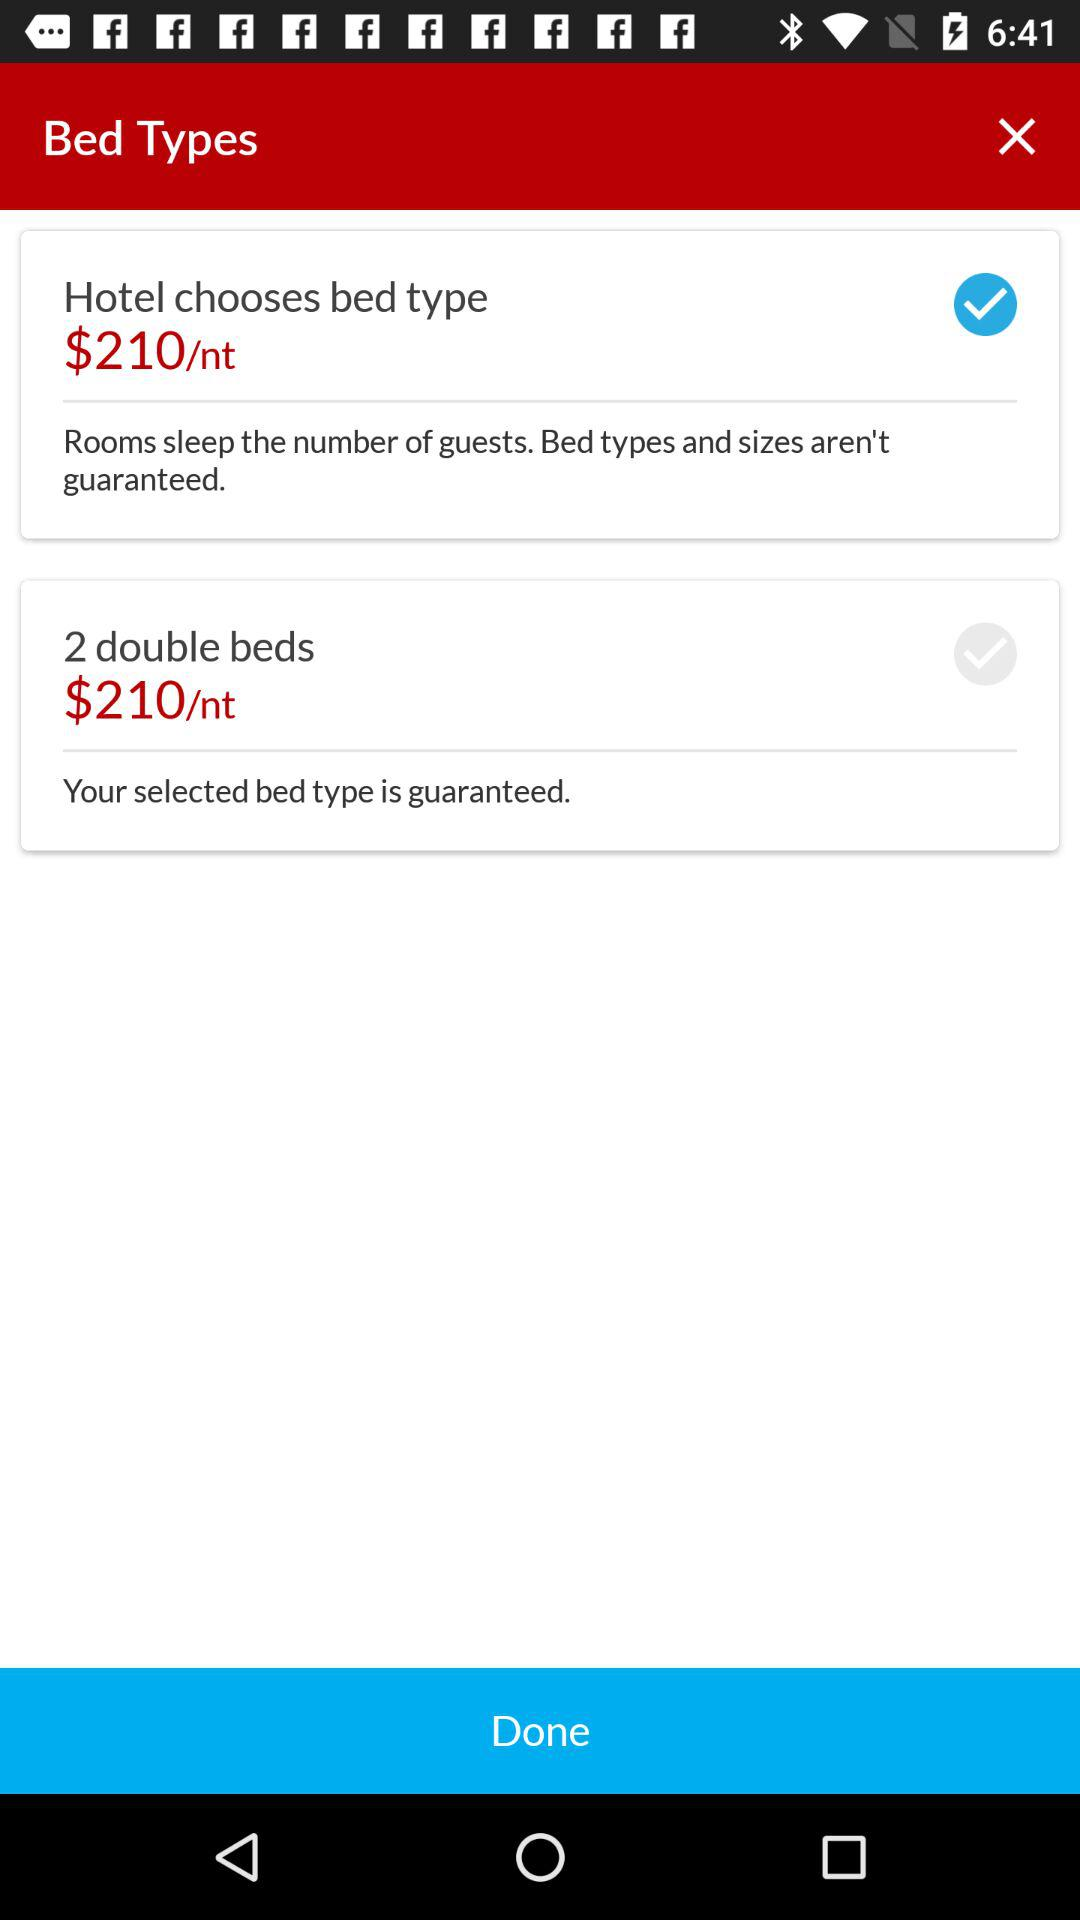How many bed types are available?
Answer the question using a single word or phrase. 2 